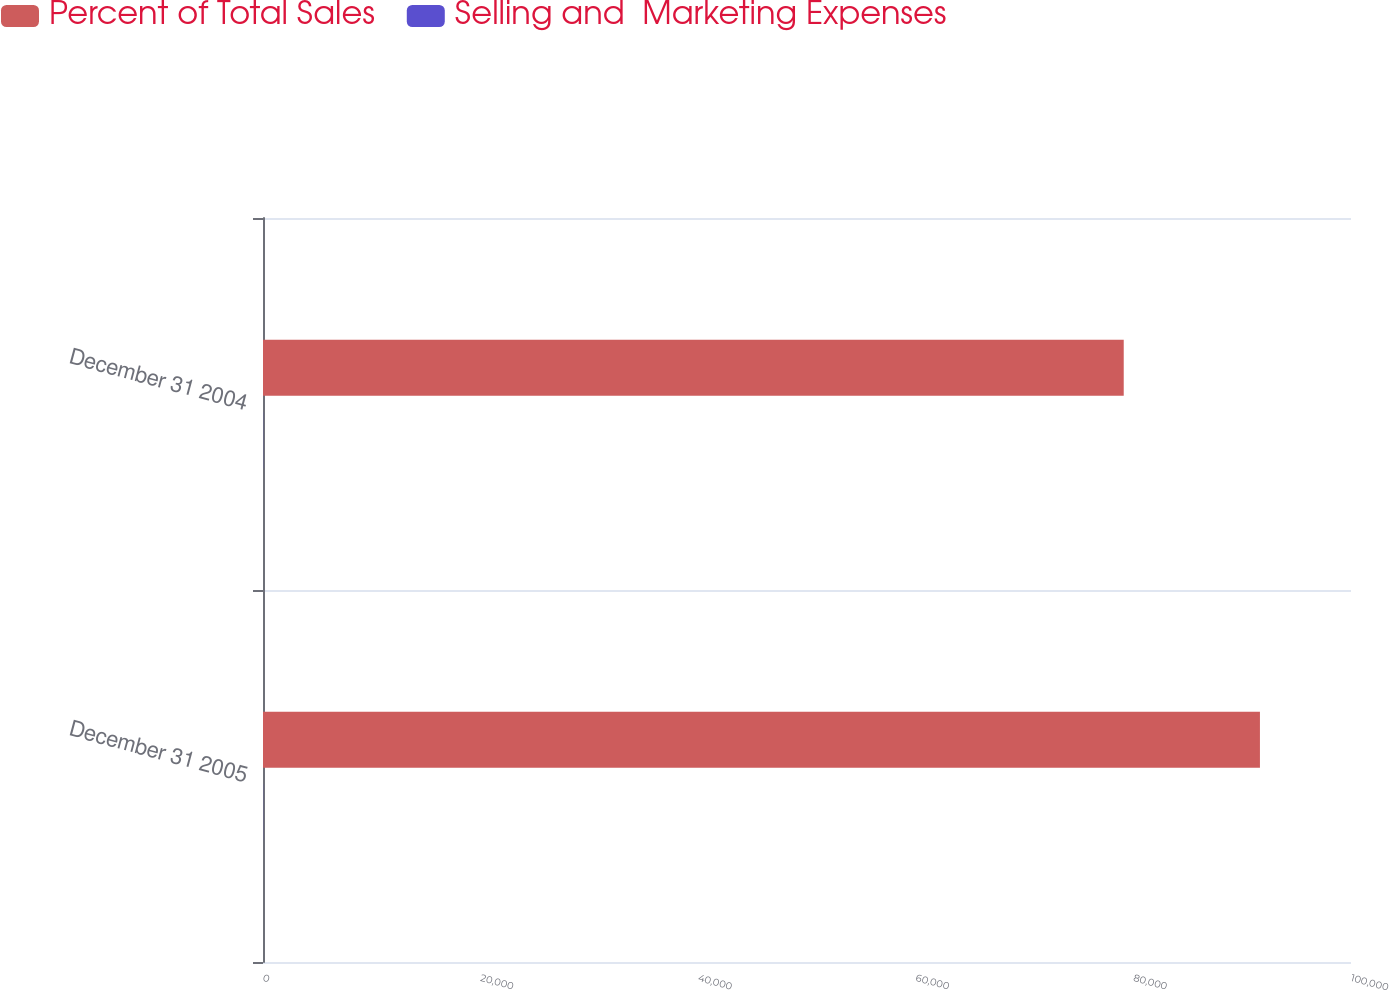<chart> <loc_0><loc_0><loc_500><loc_500><stacked_bar_chart><ecel><fcel>December 31 2005<fcel>December 31 2004<nl><fcel>Percent of Total Sales<fcel>91630<fcel>79111<nl><fcel>Selling and  Marketing Expenses<fcel>13<fcel>11.9<nl></chart> 